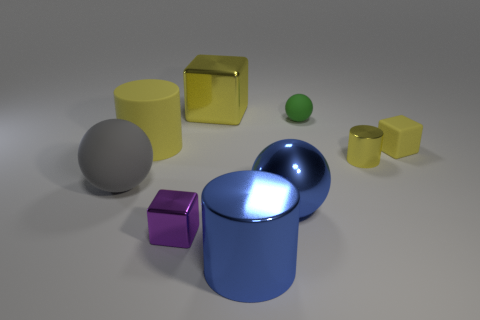What is the size of the metallic block that is the same color as the tiny cylinder?
Keep it short and to the point. Large. What number of things are yellow cylinders or big purple metal cylinders?
Your response must be concise. 2. The other cylinder that is the same size as the blue metal cylinder is what color?
Make the answer very short. Yellow. Is the shape of the gray rubber thing the same as the small shiny object that is behind the big rubber ball?
Keep it short and to the point. No. How many objects are big balls that are on the left side of the matte cube or large matte things behind the large gray rubber sphere?
Provide a succinct answer. 3. What is the shape of the tiny matte object that is the same color as the small cylinder?
Offer a terse response. Cube. There is a yellow metallic thing left of the tiny green ball; what is its shape?
Offer a very short reply. Cube. There is a blue metallic thing behind the purple metallic cube; does it have the same shape as the small purple metallic thing?
Offer a terse response. No. How many things are metal objects on the left side of the large blue cylinder or large brown matte objects?
Your answer should be very brief. 2. There is a big shiny object that is the same shape as the tiny yellow shiny thing; what is its color?
Provide a succinct answer. Blue. 